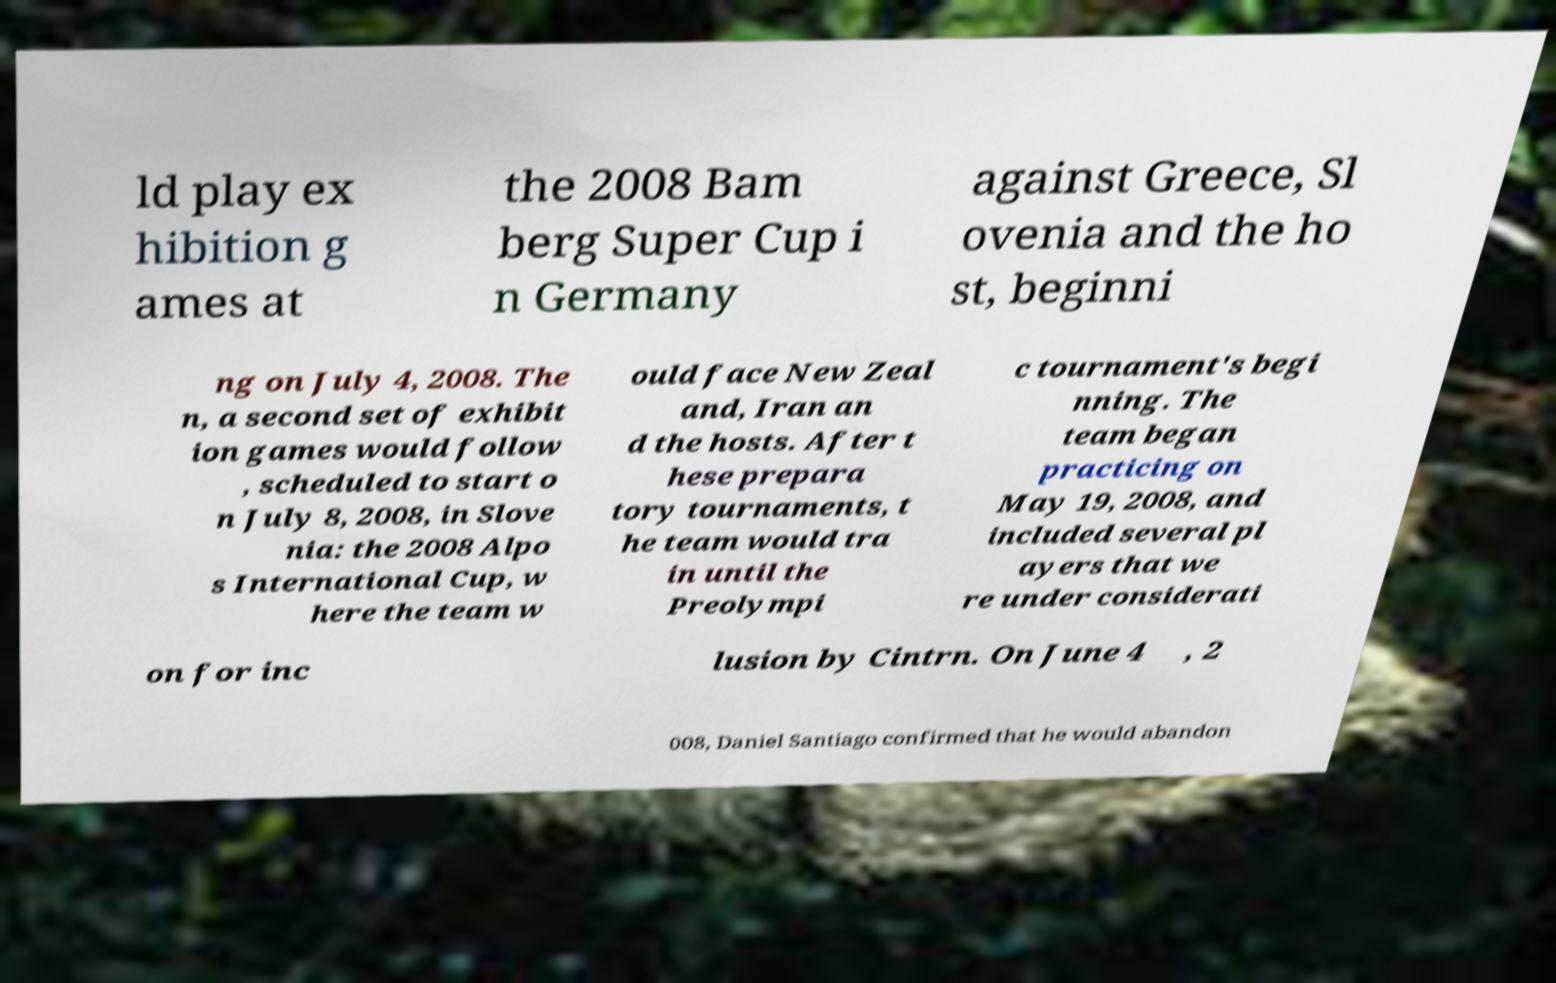For documentation purposes, I need the text within this image transcribed. Could you provide that? ld play ex hibition g ames at the 2008 Bam berg Super Cup i n Germany against Greece, Sl ovenia and the ho st, beginni ng on July 4, 2008. The n, a second set of exhibit ion games would follow , scheduled to start o n July 8, 2008, in Slove nia: the 2008 Alpo s International Cup, w here the team w ould face New Zeal and, Iran an d the hosts. After t hese prepara tory tournaments, t he team would tra in until the Preolympi c tournament's begi nning. The team began practicing on May 19, 2008, and included several pl ayers that we re under considerati on for inc lusion by Cintrn. On June 4 , 2 008, Daniel Santiago confirmed that he would abandon 